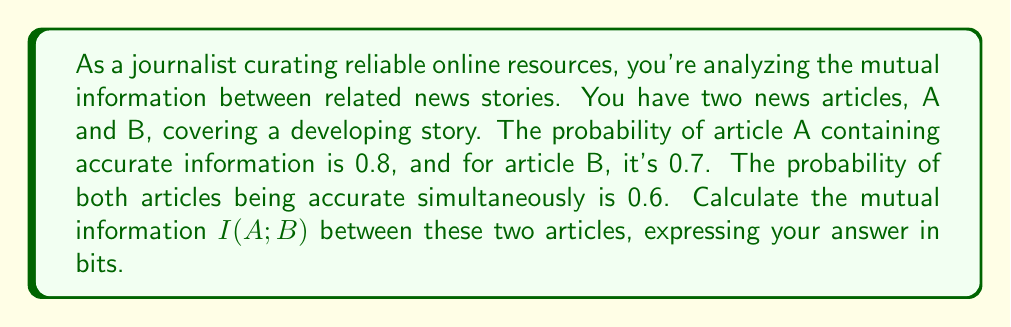Help me with this question. To calculate the mutual information between the two news articles, we'll follow these steps:

1) First, let's define our events:
   A: Article A contains accurate information
   B: Article B contains accurate information

2) We're given:
   $P(A) = 0.8$
   $P(B) = 0.7$
   $P(A \cap B) = 0.6$

3) The formula for mutual information is:
   $$I(A;B) = H(A) + H(B) - H(A,B)$$
   where $H(A)$ and $H(B)$ are the marginal entropies, and $H(A,B)$ is the joint entropy.

4) To calculate $H(A)$:
   $$H(A) = -P(A) \log_2 P(A) - P(\neg A) \log_2 P(\neg A)$$
   $$= -0.8 \log_2 0.8 - 0.2 \log_2 0.2 \approx 0.7219$$ bits

5) Similarly, for $H(B)$:
   $$H(B) = -0.7 \log_2 0.7 - 0.3 \log_2 0.3 \approx 0.8813$$ bits

6) For $H(A,B)$, we need all joint probabilities:
   $P(A \cap B) = 0.6$
   $P(A \cap \neg B) = P(A) - P(A \cap B) = 0.8 - 0.6 = 0.2$
   $P(\neg A \cap B) = P(B) - P(A \cap B) = 0.7 - 0.6 = 0.1$
   $P(\neg A \cap \neg B) = 1 - P(A) - P(B) + P(A \cap B) = 1 - 0.8 - 0.7 + 0.6 = 0.1$

7) Now we can calculate $H(A,B)$:
   $$H(A,B) = -\sum_{i,j} P(i,j) \log_2 P(i,j)$$
   $$= -0.6 \log_2 0.6 - 0.2 \log_2 0.2 - 0.1 \log_2 0.1 - 0.1 \log_2 0.1 \approx 1.5710$$ bits

8) Finally, we can calculate the mutual information:
   $$I(A;B) = H(A) + H(B) - H(A,B)$$
   $$= 0.7219 + 0.8813 - 1.5710 \approx 0.0322$$ bits
Answer: The mutual information $I(A;B)$ between the two news articles is approximately 0.0322 bits. 